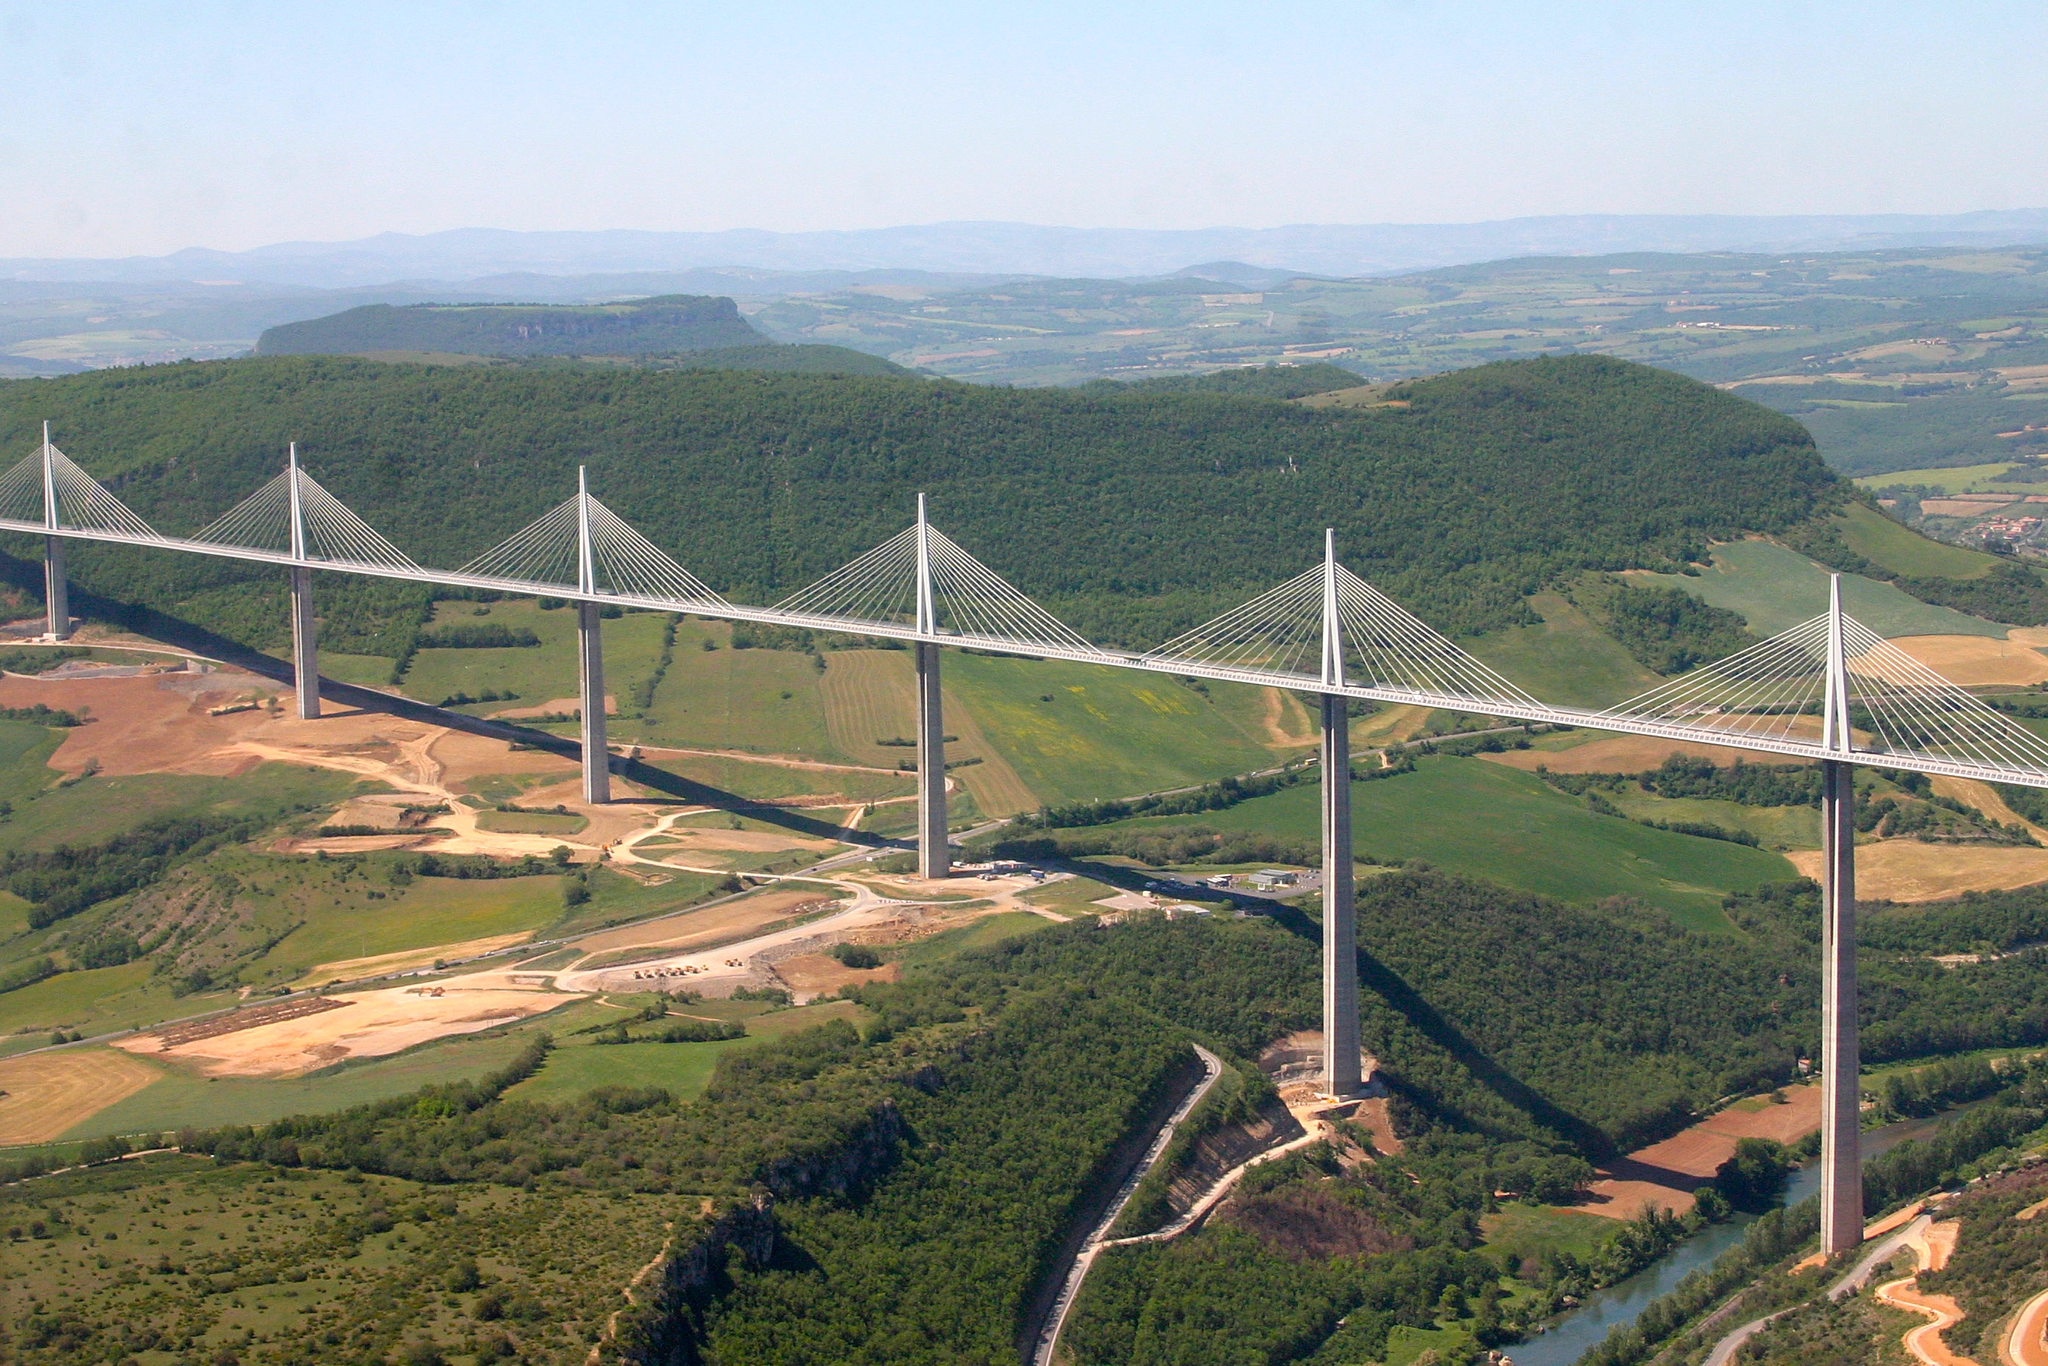How does the Millau Viaduct impact the environment and local community? The Millau Viaduct has both an environmental and socio-economic impact on the area. Environmentally, the construction was designed to have a minimal footprint, preserving much of the valley's natural ecosystem. Socio-economically, it has significantly reduced travel time across the region, boosting local tourism and improving logistics and transportation efficiency. Local communities have benefited from increased visitor numbers, and the bridge itself has become a symbol of regional pride and technological achievement. 